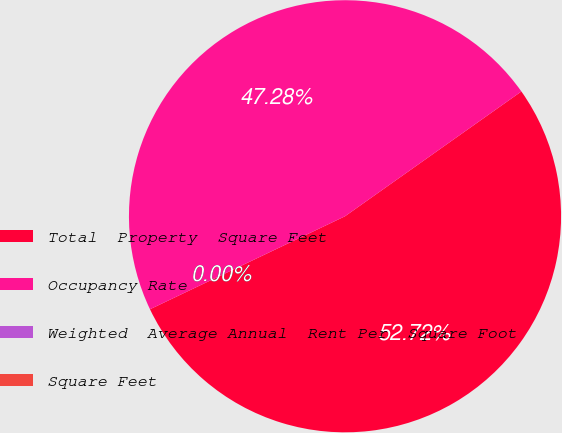Convert chart. <chart><loc_0><loc_0><loc_500><loc_500><pie_chart><fcel>Total  Property  Square Feet<fcel>Occupancy Rate<fcel>Weighted  Average Annual  Rent Per  Square Foot<fcel>Square Feet<nl><fcel>52.72%<fcel>47.28%<fcel>0.0%<fcel>0.0%<nl></chart> 